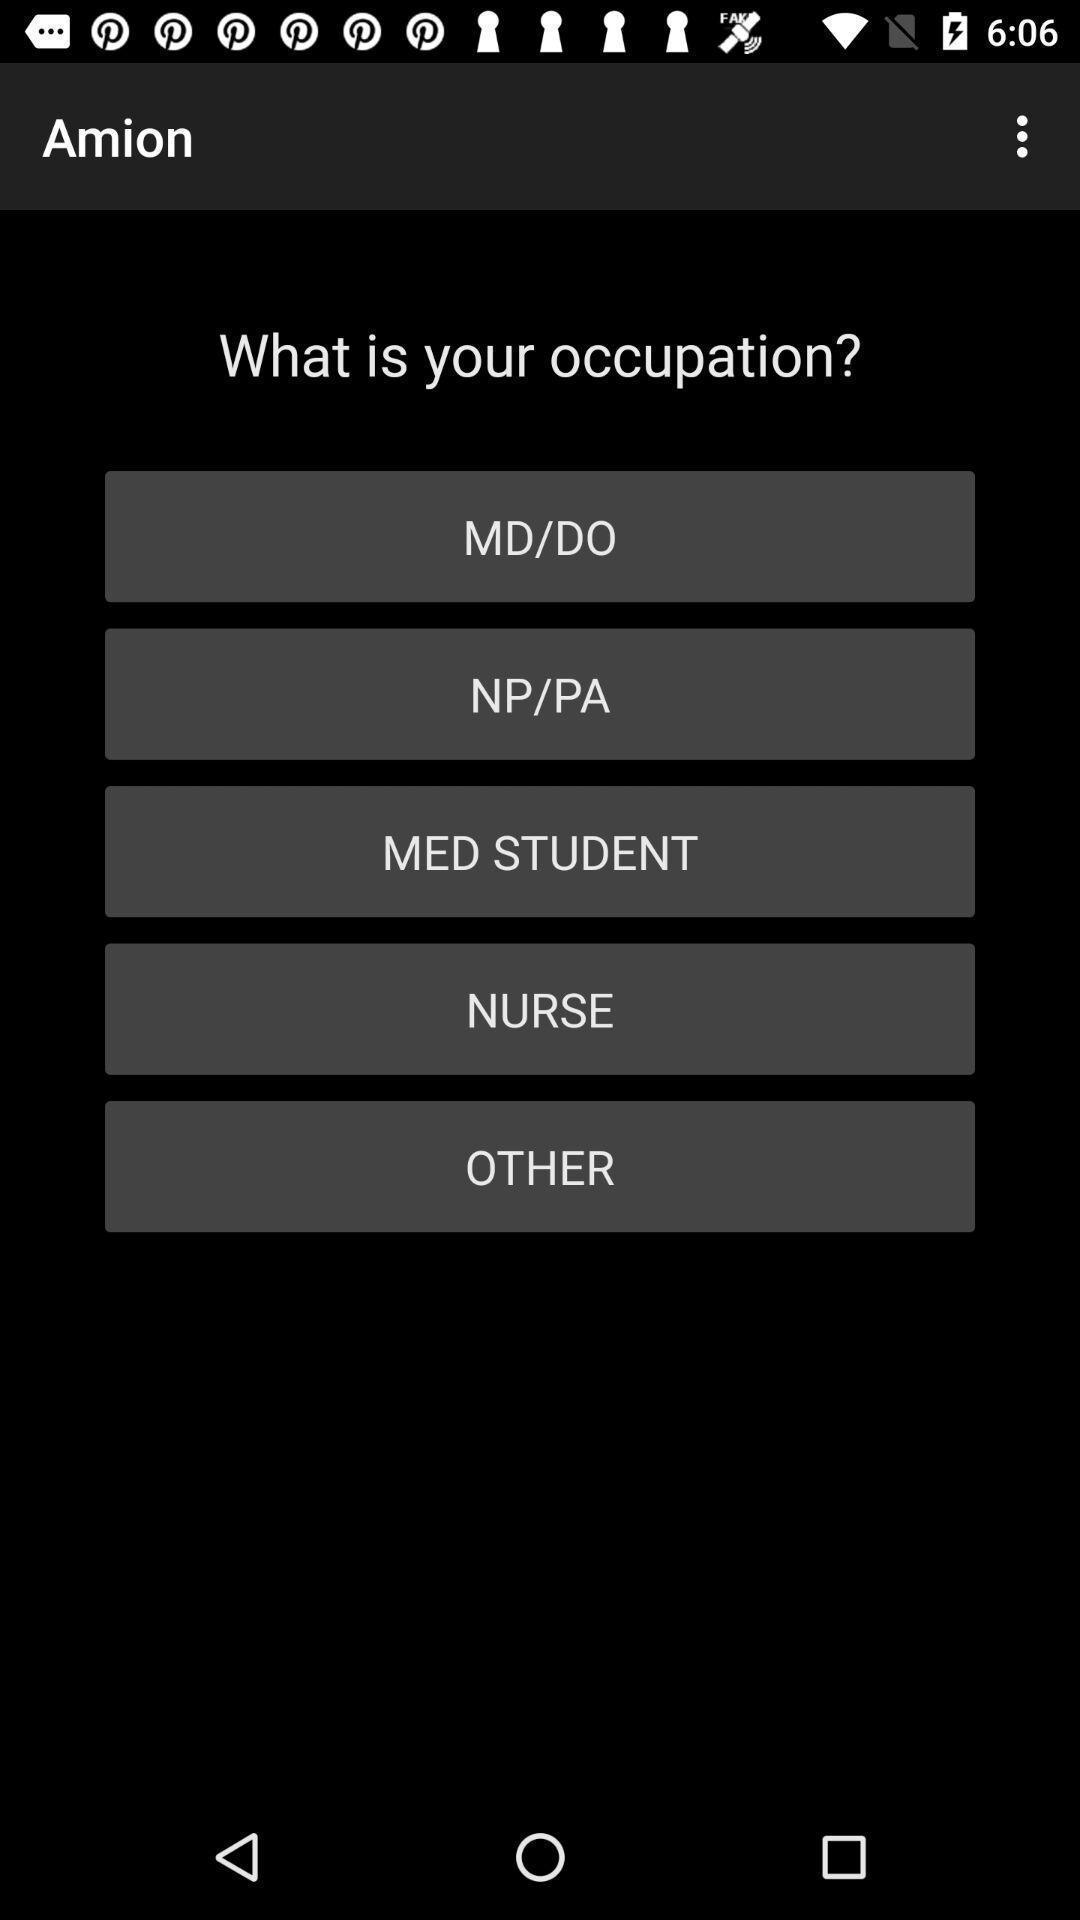Provide a description of this screenshot. Various options displayed to be selected. 